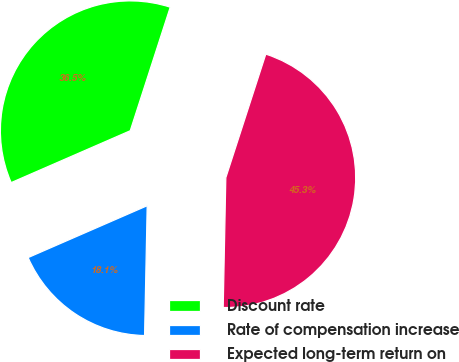<chart> <loc_0><loc_0><loc_500><loc_500><pie_chart><fcel>Discount rate<fcel>Rate of compensation increase<fcel>Expected long-term return on<nl><fcel>36.52%<fcel>18.14%<fcel>45.34%<nl></chart> 